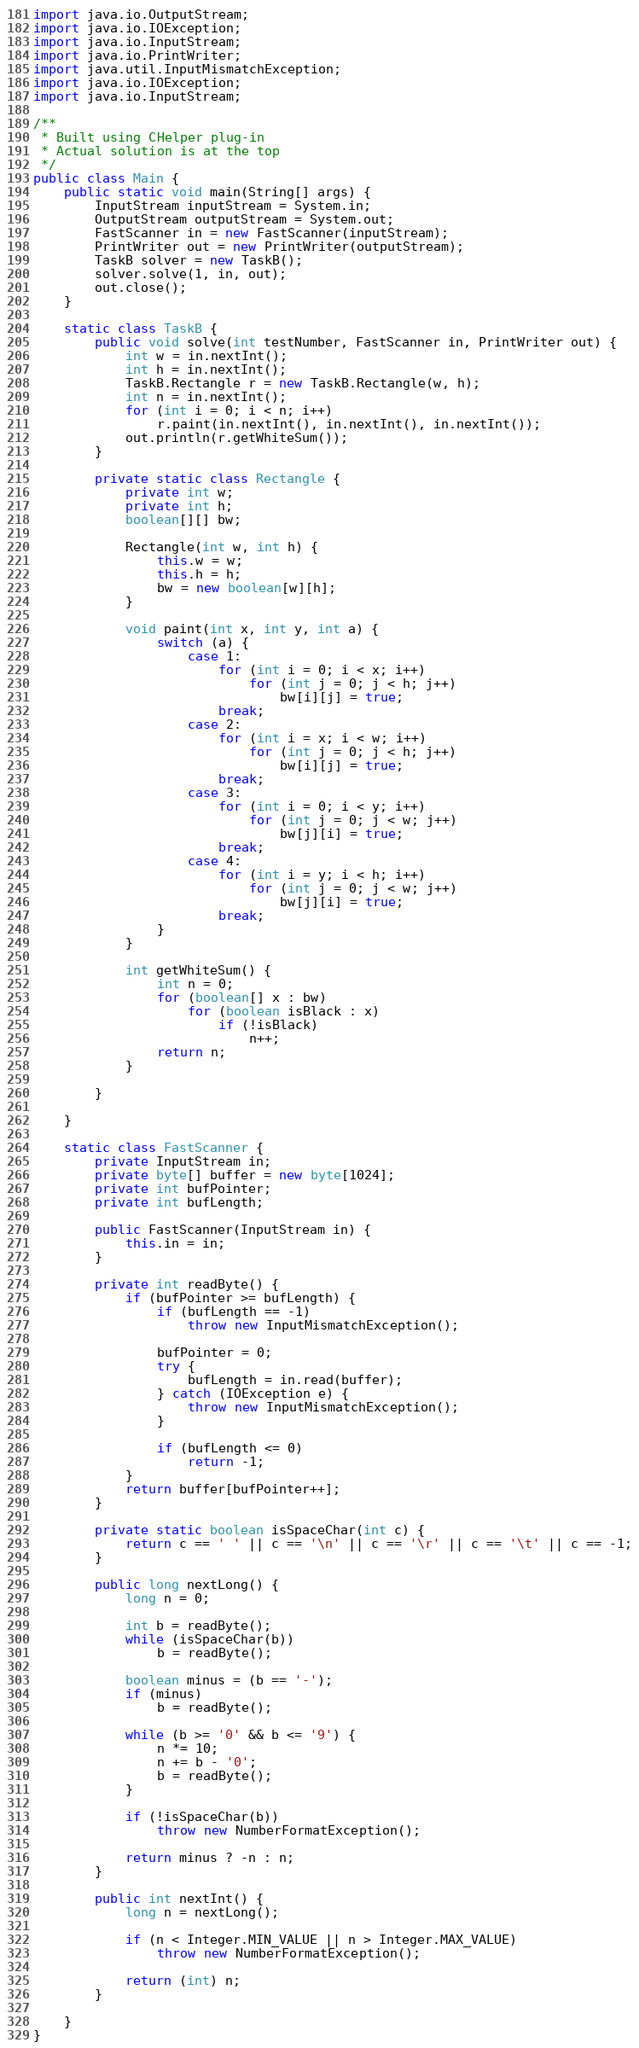<code> <loc_0><loc_0><loc_500><loc_500><_Java_>import java.io.OutputStream;
import java.io.IOException;
import java.io.InputStream;
import java.io.PrintWriter;
import java.util.InputMismatchException;
import java.io.IOException;
import java.io.InputStream;

/**
 * Built using CHelper plug-in
 * Actual solution is at the top
 */
public class Main {
    public static void main(String[] args) {
        InputStream inputStream = System.in;
        OutputStream outputStream = System.out;
        FastScanner in = new FastScanner(inputStream);
        PrintWriter out = new PrintWriter(outputStream);
        TaskB solver = new TaskB();
        solver.solve(1, in, out);
        out.close();
    }

    static class TaskB {
        public void solve(int testNumber, FastScanner in, PrintWriter out) {
            int w = in.nextInt();
            int h = in.nextInt();
            TaskB.Rectangle r = new TaskB.Rectangle(w, h);
            int n = in.nextInt();
            for (int i = 0; i < n; i++)
                r.paint(in.nextInt(), in.nextInt(), in.nextInt());
            out.println(r.getWhiteSum());
        }

        private static class Rectangle {
            private int w;
            private int h;
            boolean[][] bw;

            Rectangle(int w, int h) {
                this.w = w;
                this.h = h;
                bw = new boolean[w][h];
            }

            void paint(int x, int y, int a) {
                switch (a) {
                    case 1:
                        for (int i = 0; i < x; i++)
                            for (int j = 0; j < h; j++)
                                bw[i][j] = true;
                        break;
                    case 2:
                        for (int i = x; i < w; i++)
                            for (int j = 0; j < h; j++)
                                bw[i][j] = true;
                        break;
                    case 3:
                        for (int i = 0; i < y; i++)
                            for (int j = 0; j < w; j++)
                                bw[j][i] = true;
                        break;
                    case 4:
                        for (int i = y; i < h; i++)
                            for (int j = 0; j < w; j++)
                                bw[j][i] = true;
                        break;
                }
            }

            int getWhiteSum() {
                int n = 0;
                for (boolean[] x : bw)
                    for (boolean isBlack : x)
                        if (!isBlack)
                            n++;
                return n;
            }

        }

    }

    static class FastScanner {
        private InputStream in;
        private byte[] buffer = new byte[1024];
        private int bufPointer;
        private int bufLength;

        public FastScanner(InputStream in) {
            this.in = in;
        }

        private int readByte() {
            if (bufPointer >= bufLength) {
                if (bufLength == -1)
                    throw new InputMismatchException();

                bufPointer = 0;
                try {
                    bufLength = in.read(buffer);
                } catch (IOException e) {
                    throw new InputMismatchException();
                }

                if (bufLength <= 0)
                    return -1;
            }
            return buffer[bufPointer++];
        }

        private static boolean isSpaceChar(int c) {
            return c == ' ' || c == '\n' || c == '\r' || c == '\t' || c == -1;
        }

        public long nextLong() {
            long n = 0;

            int b = readByte();
            while (isSpaceChar(b))
                b = readByte();

            boolean minus = (b == '-');
            if (minus)
                b = readByte();

            while (b >= '0' && b <= '9') {
                n *= 10;
                n += b - '0';
                b = readByte();
            }

            if (!isSpaceChar(b))
                throw new NumberFormatException();

            return minus ? -n : n;
        }

        public int nextInt() {
            long n = nextLong();

            if (n < Integer.MIN_VALUE || n > Integer.MAX_VALUE)
                throw new NumberFormatException();

            return (int) n;
        }

    }
}

</code> 